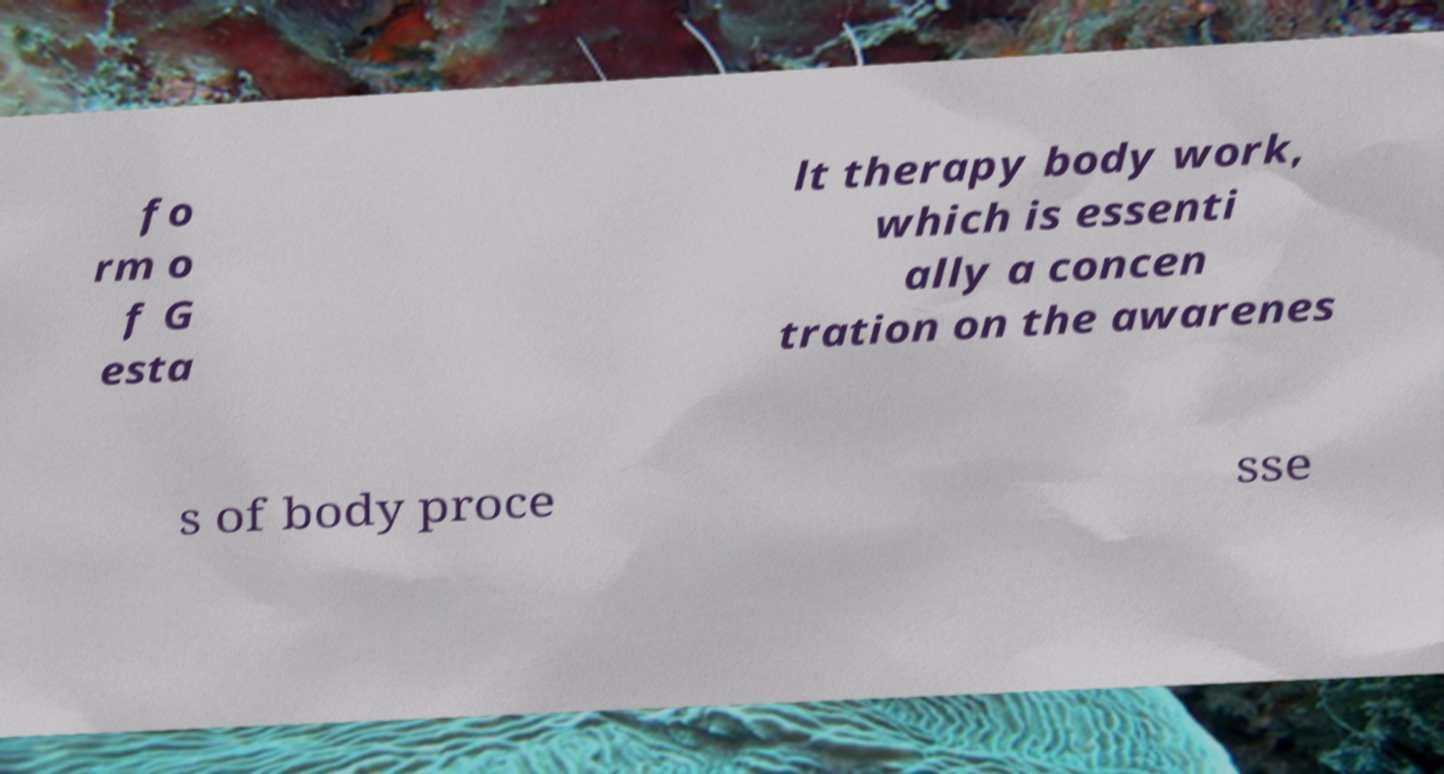I need the written content from this picture converted into text. Can you do that? fo rm o f G esta lt therapy body work, which is essenti ally a concen tration on the awarenes s of body proce sse 